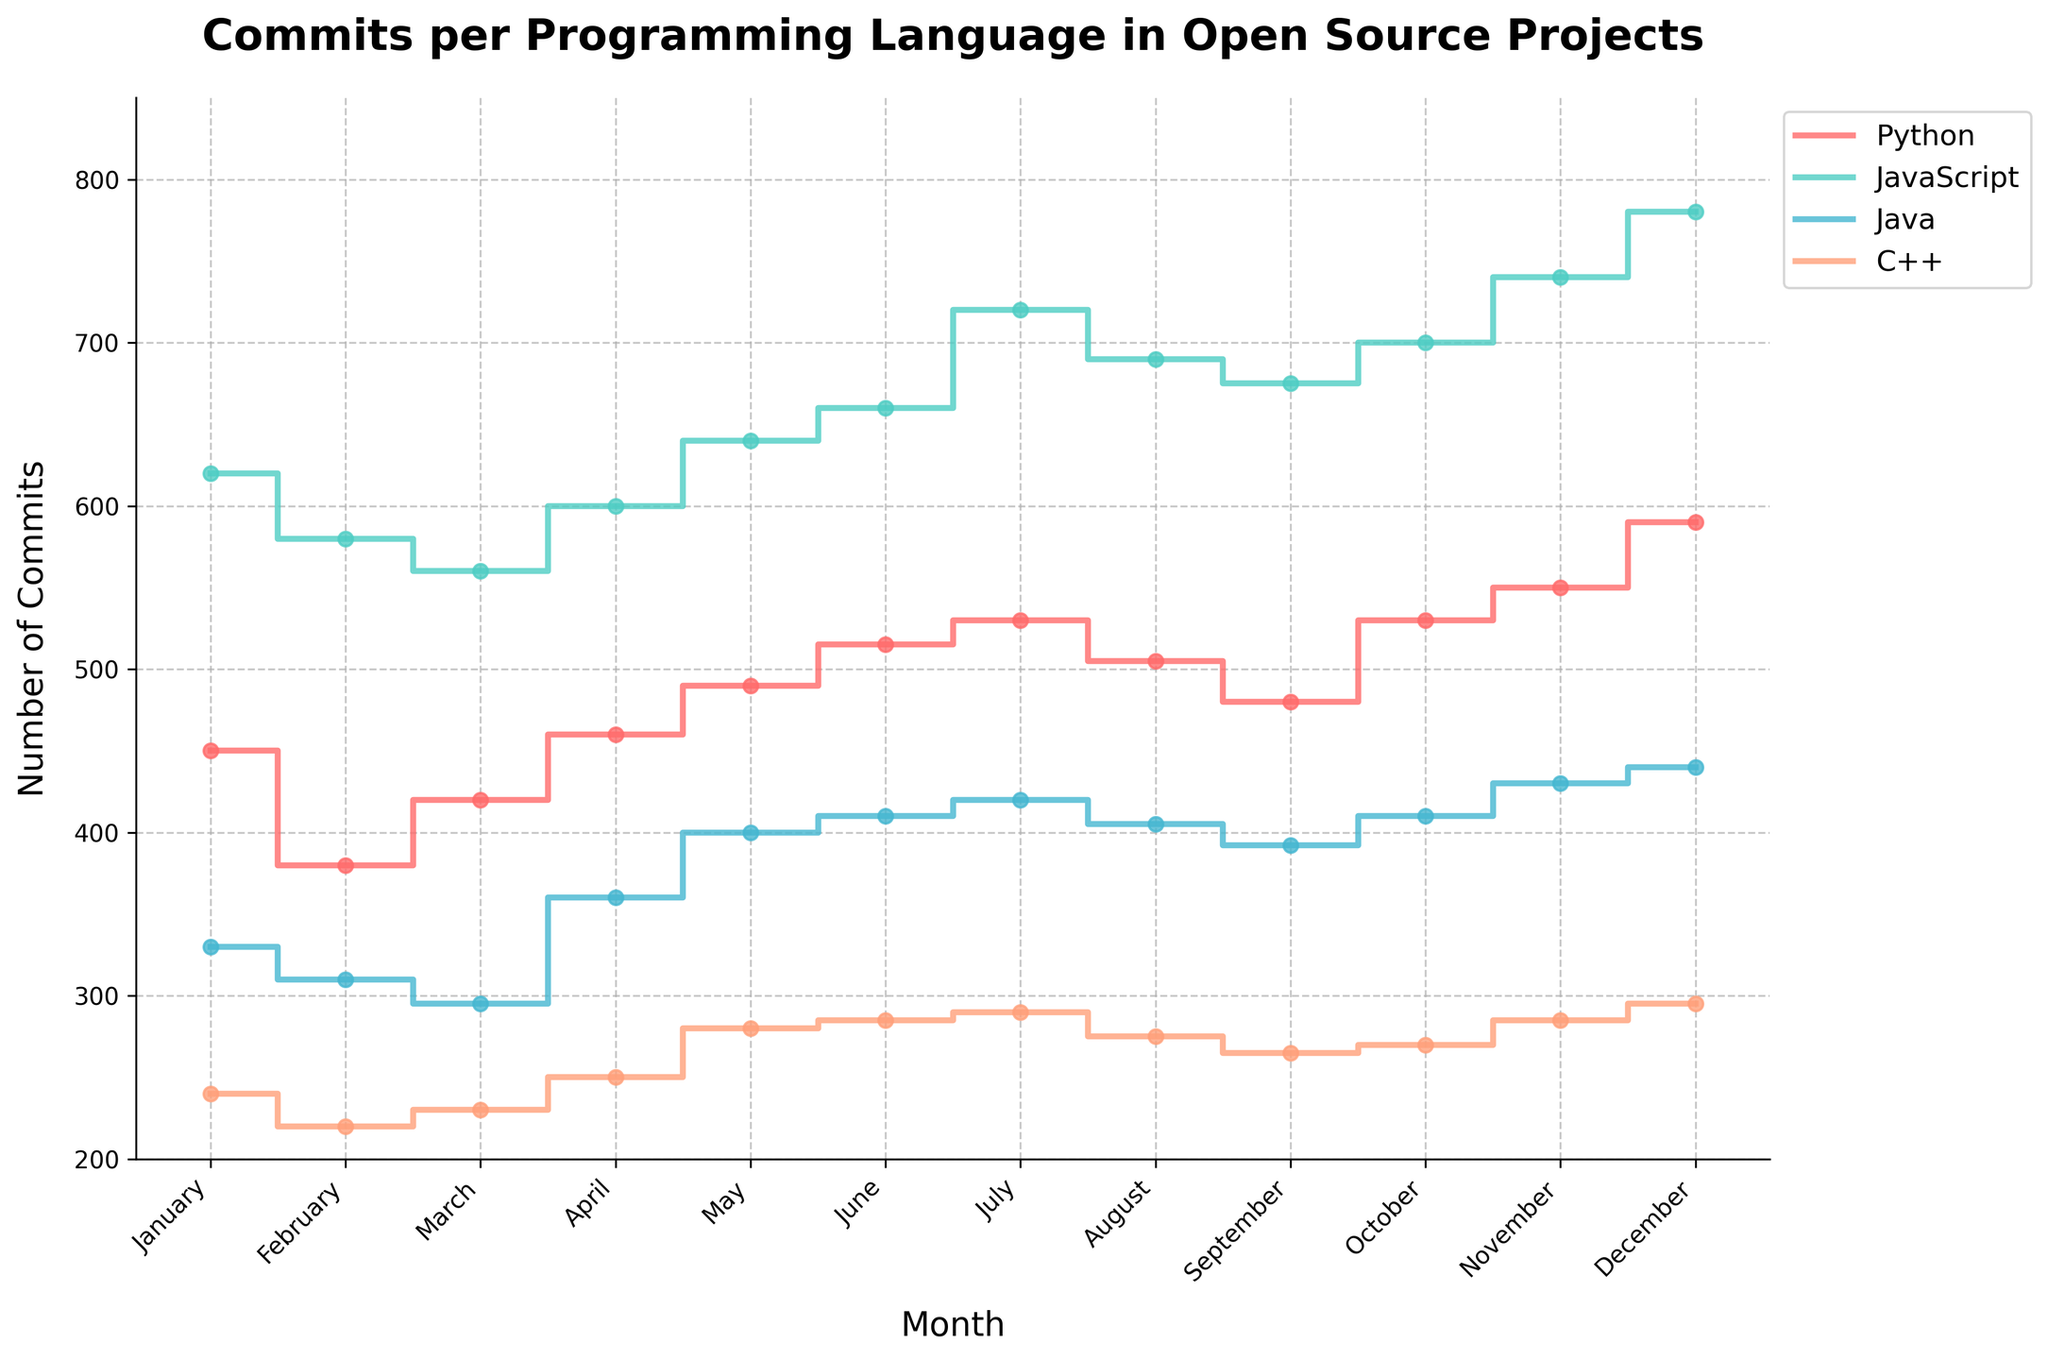What is the total number of commits for Python in December? Look at the 'Python' line in the graph, find the data point for December, and read the value of commits.
Answer: 590 Which programming language had the highest number of commits in November? Compare the commits of all languages in November by looking at the height of the steps for each color's line corresponding to November.
Answer: JavaScript How does the number of commits in January compare between Python and Java? Identify the data points for January for Python and Java and compare their commits.
Answer: Python has more commits than Java What is the average number of commits for C++ over the year? Add up the number of commits for C++ for each month, then divide by the number of months (12). Calculation: (240 + 220 + 230 + 250 + 280 + 285 + 290 + 275 + 265 + 270 + 285 + 295) / 12.
Answer: 262.5 Which month saw the highest number of commits across all programming languages? Identify the highest step on the plot for each language and see which month corresponds to the highest point overall.
Answer: December What is the increase in the number of JavaScript commits from February to March? Find the number of commits for JavaScript in February and March, then subtract the February value from the March value. Calculation: 560 - 580.
Answer: -20 Which programming language experienced the least variation in the number of commits throughout the year? Observe the range of heights of the steps for each language's line and determine which one has the smallest range between the maximum and minimum commits.
Answer: C++ What is the total number of commits for JavaScript in the second half of the year (July to December)? Sum the commits for JavaScript from July to December. Calculation: 720 + 690 + 675 + 700 + 740 + 780.
Answer: 4305 Did any programming language consistently have increasing commits every month? Analyze the steps in each line to see if any language's line always moves upward without decreasing at any point.
Answer: No 